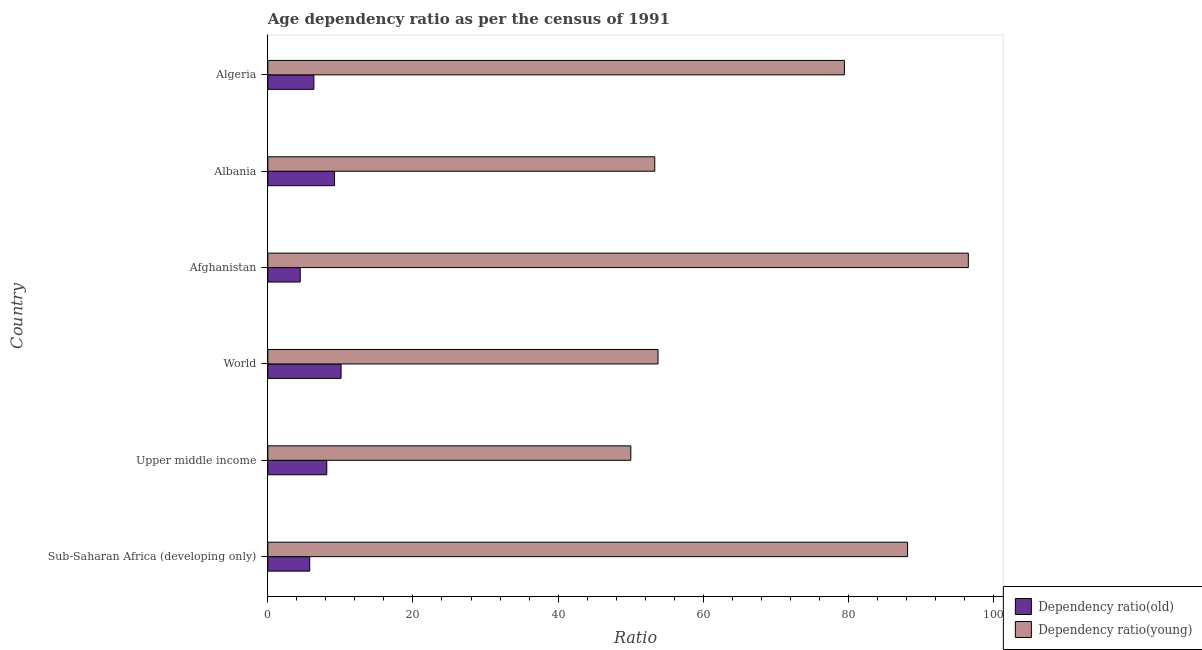How many bars are there on the 4th tick from the bottom?
Give a very brief answer. 2. What is the label of the 1st group of bars from the top?
Your answer should be very brief. Algeria. What is the age dependency ratio(young) in Afghanistan?
Offer a terse response. 96.54. Across all countries, what is the maximum age dependency ratio(young)?
Your answer should be very brief. 96.54. Across all countries, what is the minimum age dependency ratio(young)?
Give a very brief answer. 50.03. In which country was the age dependency ratio(young) maximum?
Offer a very short reply. Afghanistan. In which country was the age dependency ratio(old) minimum?
Offer a very short reply. Afghanistan. What is the total age dependency ratio(old) in the graph?
Provide a short and direct response. 43.98. What is the difference between the age dependency ratio(old) in Upper middle income and that in World?
Give a very brief answer. -1.97. What is the difference between the age dependency ratio(young) in World and the age dependency ratio(old) in Upper middle income?
Offer a terse response. 45.65. What is the average age dependency ratio(old) per country?
Keep it short and to the point. 7.33. What is the difference between the age dependency ratio(young) and age dependency ratio(old) in Afghanistan?
Ensure brevity in your answer.  92.08. What is the ratio of the age dependency ratio(old) in Albania to that in Sub-Saharan Africa (developing only)?
Make the answer very short. 1.59. Is the age dependency ratio(old) in Afghanistan less than that in Algeria?
Your response must be concise. Yes. Is the difference between the age dependency ratio(young) in Afghanistan and Albania greater than the difference between the age dependency ratio(old) in Afghanistan and Albania?
Make the answer very short. Yes. What is the difference between the highest and the second highest age dependency ratio(young)?
Make the answer very short. 8.38. What is the difference between the highest and the lowest age dependency ratio(young)?
Your answer should be compact. 46.52. Is the sum of the age dependency ratio(old) in Afghanistan and Upper middle income greater than the maximum age dependency ratio(young) across all countries?
Offer a very short reply. No. What does the 2nd bar from the top in Sub-Saharan Africa (developing only) represents?
Offer a very short reply. Dependency ratio(old). What does the 1st bar from the bottom in Upper middle income represents?
Give a very brief answer. Dependency ratio(old). How many bars are there?
Give a very brief answer. 12. Are all the bars in the graph horizontal?
Give a very brief answer. Yes. Does the graph contain grids?
Provide a short and direct response. No. How many legend labels are there?
Keep it short and to the point. 2. What is the title of the graph?
Offer a terse response. Age dependency ratio as per the census of 1991. What is the label or title of the X-axis?
Give a very brief answer. Ratio. What is the label or title of the Y-axis?
Make the answer very short. Country. What is the Ratio of Dependency ratio(old) in Sub-Saharan Africa (developing only)?
Provide a short and direct response. 5.77. What is the Ratio in Dependency ratio(young) in Sub-Saharan Africa (developing only)?
Your response must be concise. 88.17. What is the Ratio of Dependency ratio(old) in Upper middle income?
Your response must be concise. 8.12. What is the Ratio of Dependency ratio(young) in Upper middle income?
Your response must be concise. 50.03. What is the Ratio of Dependency ratio(old) in World?
Keep it short and to the point. 10.09. What is the Ratio in Dependency ratio(young) in World?
Offer a terse response. 53.77. What is the Ratio in Dependency ratio(old) in Afghanistan?
Offer a terse response. 4.46. What is the Ratio in Dependency ratio(young) in Afghanistan?
Provide a succinct answer. 96.54. What is the Ratio of Dependency ratio(old) in Albania?
Provide a succinct answer. 9.19. What is the Ratio in Dependency ratio(young) in Albania?
Ensure brevity in your answer.  53.33. What is the Ratio in Dependency ratio(old) in Algeria?
Make the answer very short. 6.34. What is the Ratio in Dependency ratio(young) in Algeria?
Your answer should be compact. 79.46. Across all countries, what is the maximum Ratio of Dependency ratio(old)?
Your response must be concise. 10.09. Across all countries, what is the maximum Ratio of Dependency ratio(young)?
Provide a succinct answer. 96.54. Across all countries, what is the minimum Ratio of Dependency ratio(old)?
Keep it short and to the point. 4.46. Across all countries, what is the minimum Ratio in Dependency ratio(young)?
Ensure brevity in your answer.  50.03. What is the total Ratio of Dependency ratio(old) in the graph?
Your answer should be compact. 43.98. What is the total Ratio in Dependency ratio(young) in the graph?
Offer a very short reply. 421.3. What is the difference between the Ratio in Dependency ratio(old) in Sub-Saharan Africa (developing only) and that in Upper middle income?
Provide a succinct answer. -2.36. What is the difference between the Ratio of Dependency ratio(young) in Sub-Saharan Africa (developing only) and that in Upper middle income?
Ensure brevity in your answer.  38.14. What is the difference between the Ratio in Dependency ratio(old) in Sub-Saharan Africa (developing only) and that in World?
Offer a terse response. -4.33. What is the difference between the Ratio of Dependency ratio(young) in Sub-Saharan Africa (developing only) and that in World?
Provide a short and direct response. 34.39. What is the difference between the Ratio in Dependency ratio(old) in Sub-Saharan Africa (developing only) and that in Afghanistan?
Keep it short and to the point. 1.3. What is the difference between the Ratio of Dependency ratio(young) in Sub-Saharan Africa (developing only) and that in Afghanistan?
Your response must be concise. -8.38. What is the difference between the Ratio in Dependency ratio(old) in Sub-Saharan Africa (developing only) and that in Albania?
Make the answer very short. -3.43. What is the difference between the Ratio in Dependency ratio(young) in Sub-Saharan Africa (developing only) and that in Albania?
Offer a very short reply. 34.84. What is the difference between the Ratio in Dependency ratio(old) in Sub-Saharan Africa (developing only) and that in Algeria?
Ensure brevity in your answer.  -0.58. What is the difference between the Ratio of Dependency ratio(young) in Sub-Saharan Africa (developing only) and that in Algeria?
Provide a short and direct response. 8.7. What is the difference between the Ratio of Dependency ratio(old) in Upper middle income and that in World?
Ensure brevity in your answer.  -1.97. What is the difference between the Ratio in Dependency ratio(young) in Upper middle income and that in World?
Your response must be concise. -3.75. What is the difference between the Ratio of Dependency ratio(old) in Upper middle income and that in Afghanistan?
Your answer should be compact. 3.66. What is the difference between the Ratio in Dependency ratio(young) in Upper middle income and that in Afghanistan?
Ensure brevity in your answer.  -46.52. What is the difference between the Ratio of Dependency ratio(old) in Upper middle income and that in Albania?
Your answer should be very brief. -1.07. What is the difference between the Ratio of Dependency ratio(young) in Upper middle income and that in Albania?
Provide a short and direct response. -3.3. What is the difference between the Ratio in Dependency ratio(old) in Upper middle income and that in Algeria?
Your answer should be very brief. 1.78. What is the difference between the Ratio of Dependency ratio(young) in Upper middle income and that in Algeria?
Provide a short and direct response. -29.44. What is the difference between the Ratio of Dependency ratio(old) in World and that in Afghanistan?
Keep it short and to the point. 5.63. What is the difference between the Ratio in Dependency ratio(young) in World and that in Afghanistan?
Your answer should be compact. -42.77. What is the difference between the Ratio in Dependency ratio(old) in World and that in Albania?
Provide a succinct answer. 0.9. What is the difference between the Ratio of Dependency ratio(young) in World and that in Albania?
Provide a short and direct response. 0.45. What is the difference between the Ratio of Dependency ratio(old) in World and that in Algeria?
Ensure brevity in your answer.  3.75. What is the difference between the Ratio of Dependency ratio(young) in World and that in Algeria?
Make the answer very short. -25.69. What is the difference between the Ratio in Dependency ratio(old) in Afghanistan and that in Albania?
Offer a very short reply. -4.73. What is the difference between the Ratio of Dependency ratio(young) in Afghanistan and that in Albania?
Provide a short and direct response. 43.22. What is the difference between the Ratio in Dependency ratio(old) in Afghanistan and that in Algeria?
Your answer should be very brief. -1.88. What is the difference between the Ratio in Dependency ratio(young) in Afghanistan and that in Algeria?
Offer a terse response. 17.08. What is the difference between the Ratio of Dependency ratio(old) in Albania and that in Algeria?
Provide a succinct answer. 2.85. What is the difference between the Ratio of Dependency ratio(young) in Albania and that in Algeria?
Provide a succinct answer. -26.14. What is the difference between the Ratio in Dependency ratio(old) in Sub-Saharan Africa (developing only) and the Ratio in Dependency ratio(young) in Upper middle income?
Give a very brief answer. -44.26. What is the difference between the Ratio of Dependency ratio(old) in Sub-Saharan Africa (developing only) and the Ratio of Dependency ratio(young) in World?
Give a very brief answer. -48.01. What is the difference between the Ratio of Dependency ratio(old) in Sub-Saharan Africa (developing only) and the Ratio of Dependency ratio(young) in Afghanistan?
Offer a terse response. -90.78. What is the difference between the Ratio in Dependency ratio(old) in Sub-Saharan Africa (developing only) and the Ratio in Dependency ratio(young) in Albania?
Give a very brief answer. -47.56. What is the difference between the Ratio of Dependency ratio(old) in Sub-Saharan Africa (developing only) and the Ratio of Dependency ratio(young) in Algeria?
Your answer should be very brief. -73.7. What is the difference between the Ratio in Dependency ratio(old) in Upper middle income and the Ratio in Dependency ratio(young) in World?
Your answer should be very brief. -45.65. What is the difference between the Ratio in Dependency ratio(old) in Upper middle income and the Ratio in Dependency ratio(young) in Afghanistan?
Give a very brief answer. -88.42. What is the difference between the Ratio of Dependency ratio(old) in Upper middle income and the Ratio of Dependency ratio(young) in Albania?
Provide a short and direct response. -45.2. What is the difference between the Ratio of Dependency ratio(old) in Upper middle income and the Ratio of Dependency ratio(young) in Algeria?
Provide a short and direct response. -71.34. What is the difference between the Ratio in Dependency ratio(old) in World and the Ratio in Dependency ratio(young) in Afghanistan?
Provide a short and direct response. -86.45. What is the difference between the Ratio in Dependency ratio(old) in World and the Ratio in Dependency ratio(young) in Albania?
Offer a terse response. -43.23. What is the difference between the Ratio of Dependency ratio(old) in World and the Ratio of Dependency ratio(young) in Algeria?
Give a very brief answer. -69.37. What is the difference between the Ratio in Dependency ratio(old) in Afghanistan and the Ratio in Dependency ratio(young) in Albania?
Give a very brief answer. -48.86. What is the difference between the Ratio in Dependency ratio(old) in Afghanistan and the Ratio in Dependency ratio(young) in Algeria?
Your answer should be very brief. -75. What is the difference between the Ratio in Dependency ratio(old) in Albania and the Ratio in Dependency ratio(young) in Algeria?
Your response must be concise. -70.27. What is the average Ratio in Dependency ratio(old) per country?
Provide a short and direct response. 7.33. What is the average Ratio of Dependency ratio(young) per country?
Offer a terse response. 70.22. What is the difference between the Ratio in Dependency ratio(old) and Ratio in Dependency ratio(young) in Sub-Saharan Africa (developing only)?
Your answer should be very brief. -82.4. What is the difference between the Ratio of Dependency ratio(old) and Ratio of Dependency ratio(young) in Upper middle income?
Provide a succinct answer. -41.91. What is the difference between the Ratio in Dependency ratio(old) and Ratio in Dependency ratio(young) in World?
Your answer should be compact. -43.68. What is the difference between the Ratio in Dependency ratio(old) and Ratio in Dependency ratio(young) in Afghanistan?
Your answer should be very brief. -92.08. What is the difference between the Ratio in Dependency ratio(old) and Ratio in Dependency ratio(young) in Albania?
Ensure brevity in your answer.  -44.13. What is the difference between the Ratio of Dependency ratio(old) and Ratio of Dependency ratio(young) in Algeria?
Your answer should be very brief. -73.12. What is the ratio of the Ratio of Dependency ratio(old) in Sub-Saharan Africa (developing only) to that in Upper middle income?
Your answer should be compact. 0.71. What is the ratio of the Ratio of Dependency ratio(young) in Sub-Saharan Africa (developing only) to that in Upper middle income?
Your response must be concise. 1.76. What is the ratio of the Ratio of Dependency ratio(old) in Sub-Saharan Africa (developing only) to that in World?
Provide a succinct answer. 0.57. What is the ratio of the Ratio in Dependency ratio(young) in Sub-Saharan Africa (developing only) to that in World?
Keep it short and to the point. 1.64. What is the ratio of the Ratio in Dependency ratio(old) in Sub-Saharan Africa (developing only) to that in Afghanistan?
Keep it short and to the point. 1.29. What is the ratio of the Ratio of Dependency ratio(young) in Sub-Saharan Africa (developing only) to that in Afghanistan?
Offer a very short reply. 0.91. What is the ratio of the Ratio of Dependency ratio(old) in Sub-Saharan Africa (developing only) to that in Albania?
Your answer should be compact. 0.63. What is the ratio of the Ratio in Dependency ratio(young) in Sub-Saharan Africa (developing only) to that in Albania?
Offer a very short reply. 1.65. What is the ratio of the Ratio in Dependency ratio(young) in Sub-Saharan Africa (developing only) to that in Algeria?
Make the answer very short. 1.11. What is the ratio of the Ratio of Dependency ratio(old) in Upper middle income to that in World?
Ensure brevity in your answer.  0.8. What is the ratio of the Ratio of Dependency ratio(young) in Upper middle income to that in World?
Ensure brevity in your answer.  0.93. What is the ratio of the Ratio in Dependency ratio(old) in Upper middle income to that in Afghanistan?
Provide a short and direct response. 1.82. What is the ratio of the Ratio of Dependency ratio(young) in Upper middle income to that in Afghanistan?
Offer a terse response. 0.52. What is the ratio of the Ratio of Dependency ratio(old) in Upper middle income to that in Albania?
Offer a very short reply. 0.88. What is the ratio of the Ratio of Dependency ratio(young) in Upper middle income to that in Albania?
Keep it short and to the point. 0.94. What is the ratio of the Ratio of Dependency ratio(old) in Upper middle income to that in Algeria?
Provide a short and direct response. 1.28. What is the ratio of the Ratio in Dependency ratio(young) in Upper middle income to that in Algeria?
Your answer should be compact. 0.63. What is the ratio of the Ratio of Dependency ratio(old) in World to that in Afghanistan?
Make the answer very short. 2.26. What is the ratio of the Ratio of Dependency ratio(young) in World to that in Afghanistan?
Offer a very short reply. 0.56. What is the ratio of the Ratio in Dependency ratio(old) in World to that in Albania?
Your answer should be compact. 1.1. What is the ratio of the Ratio of Dependency ratio(young) in World to that in Albania?
Give a very brief answer. 1.01. What is the ratio of the Ratio of Dependency ratio(old) in World to that in Algeria?
Your answer should be very brief. 1.59. What is the ratio of the Ratio of Dependency ratio(young) in World to that in Algeria?
Provide a succinct answer. 0.68. What is the ratio of the Ratio of Dependency ratio(old) in Afghanistan to that in Albania?
Offer a very short reply. 0.49. What is the ratio of the Ratio in Dependency ratio(young) in Afghanistan to that in Albania?
Provide a succinct answer. 1.81. What is the ratio of the Ratio in Dependency ratio(old) in Afghanistan to that in Algeria?
Give a very brief answer. 0.7. What is the ratio of the Ratio in Dependency ratio(young) in Afghanistan to that in Algeria?
Keep it short and to the point. 1.21. What is the ratio of the Ratio of Dependency ratio(old) in Albania to that in Algeria?
Offer a very short reply. 1.45. What is the ratio of the Ratio of Dependency ratio(young) in Albania to that in Algeria?
Your answer should be compact. 0.67. What is the difference between the highest and the second highest Ratio of Dependency ratio(old)?
Your answer should be very brief. 0.9. What is the difference between the highest and the second highest Ratio in Dependency ratio(young)?
Your answer should be compact. 8.38. What is the difference between the highest and the lowest Ratio of Dependency ratio(old)?
Give a very brief answer. 5.63. What is the difference between the highest and the lowest Ratio in Dependency ratio(young)?
Your answer should be compact. 46.52. 